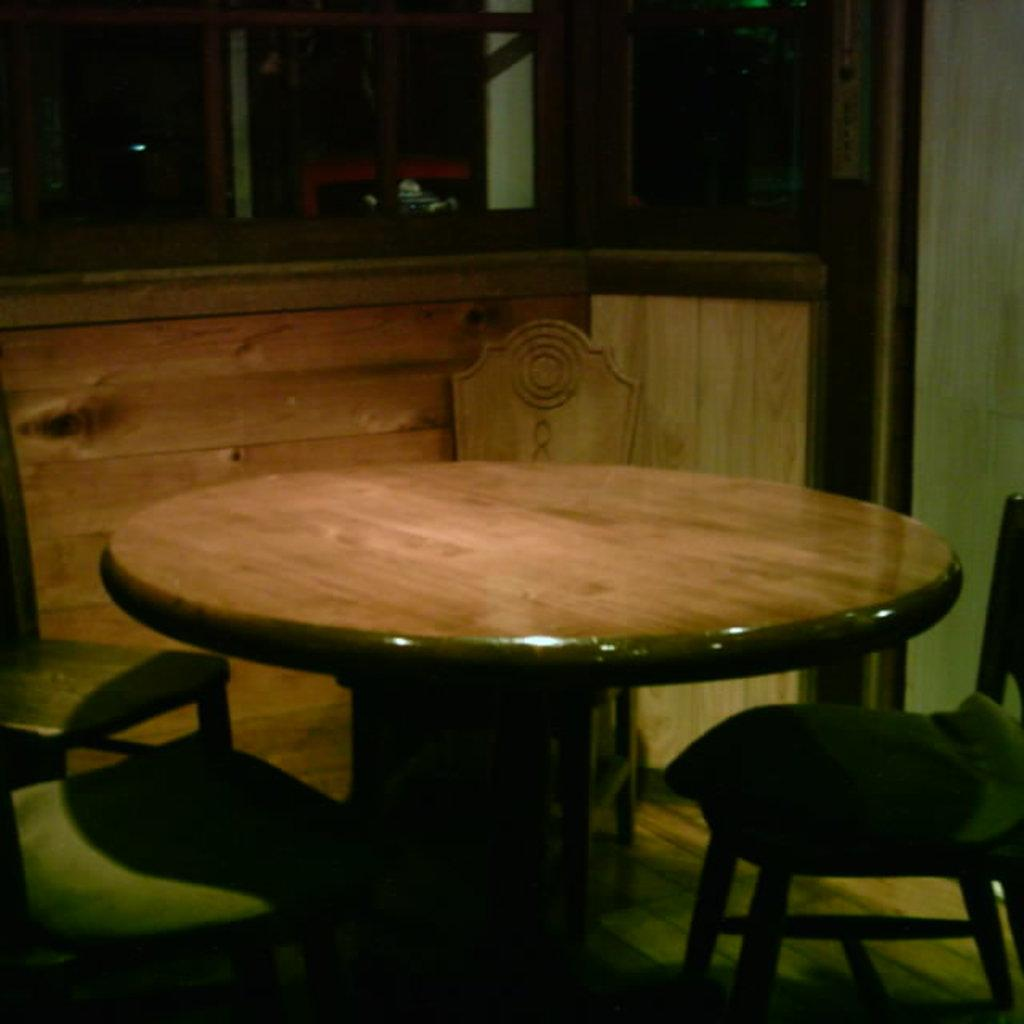What electronic device is visible in the image? There is a tablet in the image. What type of furniture is present around the table? There are chairs around the table. What can be seen in the background of the image? There is a wall in the background of the image. What type of silk is being used to create the wind in the image? There is no silk or wind present in the image; it features a tablet and chairs around a table. What type of journey is depicted in the image? There is no journey depicted in the image; it features a tablet and chairs around a table. 